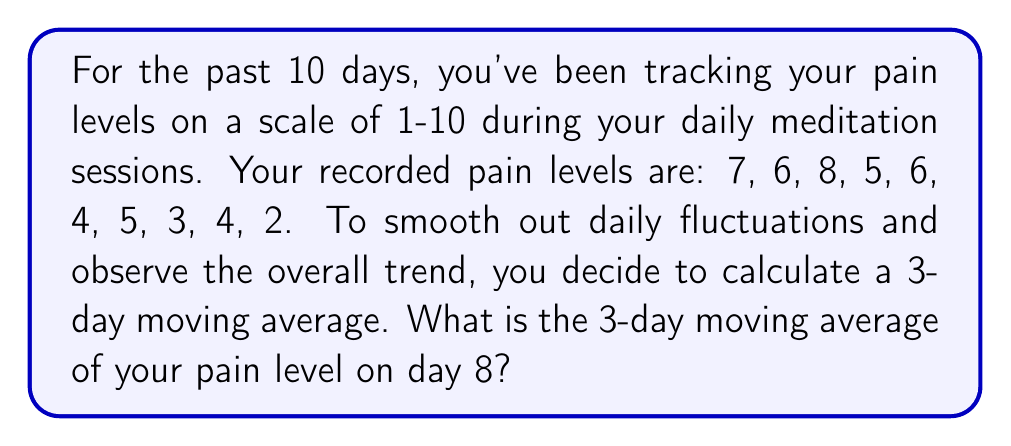Solve this math problem. To calculate a 3-day moving average, we need to:

1. Take the average of 3 consecutive days' pain levels.
2. Move this "window" of 3 days forward by one day each time.

The formula for a 3-day moving average is:

$$ MA_3 = \frac{x_{t-2} + x_{t-1} + x_t}{3} $$

Where $MA_3$ is the 3-day moving average, and $x_t$ is the pain level on day $t$.

For day 8, we need to consider the pain levels of days 6, 7, and 8:

Day 6: 4
Day 7: 5
Day 8: 3

Applying the formula:

$$ MA_3 = \frac{4 + 5 + 3}{3} = \frac{12}{3} = 4 $$

Therefore, the 3-day moving average of your pain level on day 8 is 4.

This moving average helps smooth out daily fluctuations and allows you to see the general trend in your pain levels over time, which can be useful for assessing the effectiveness of your meditation practice on pain management.
Answer: 4 